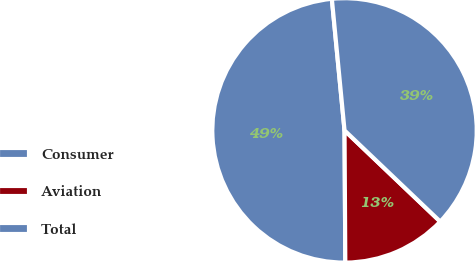<chart> <loc_0><loc_0><loc_500><loc_500><pie_chart><fcel>Consumer<fcel>Aviation<fcel>Total<nl><fcel>48.56%<fcel>12.79%<fcel>38.64%<nl></chart> 